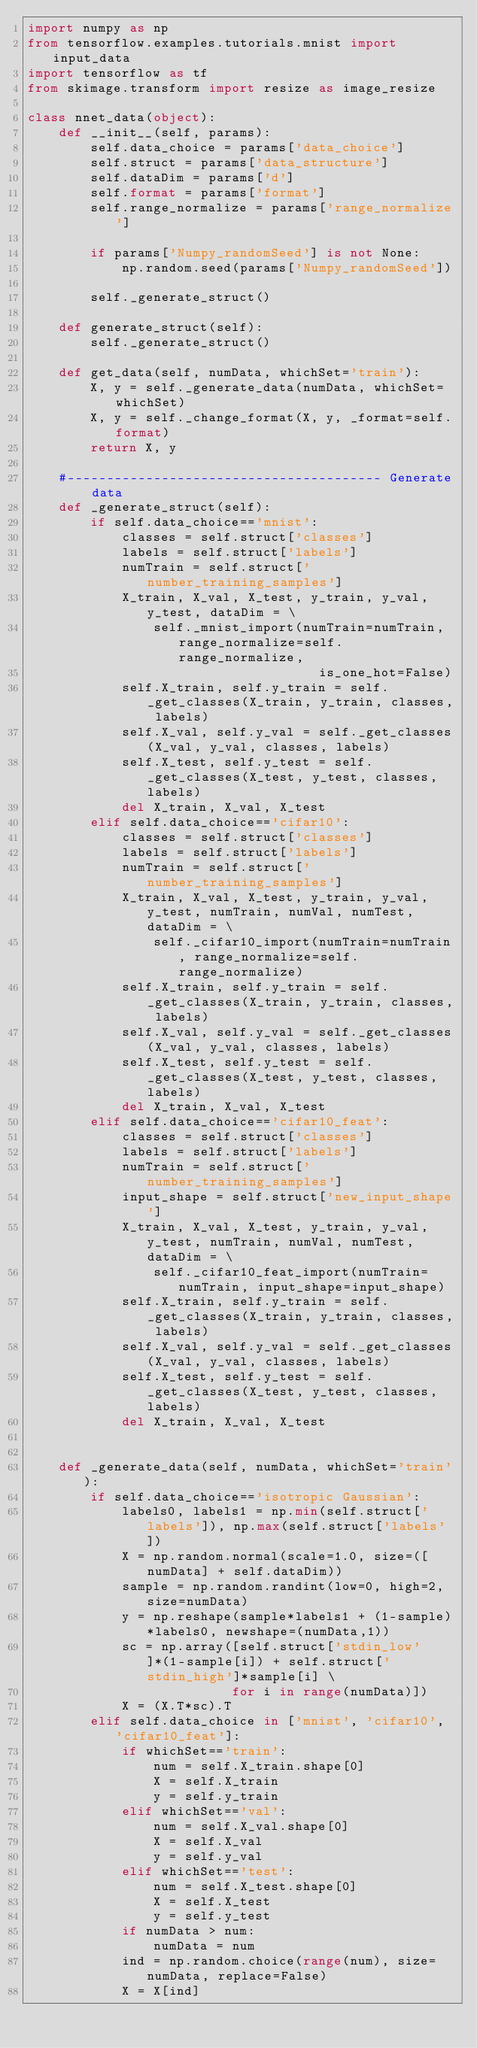<code> <loc_0><loc_0><loc_500><loc_500><_Python_>import numpy as np
from tensorflow.examples.tutorials.mnist import input_data
import tensorflow as tf
from skimage.transform import resize as image_resize

class nnet_data(object):
    def __init__(self, params):
        self.data_choice = params['data_choice']
        self.struct = params['data_structure']
        self.dataDim = params['d']
        self.format = params['format']
        self.range_normalize = params['range_normalize']
        
        if params['Numpy_randomSeed'] is not None:
            np.random.seed(params['Numpy_randomSeed'])                 
        
        self._generate_struct()
            
    def generate_struct(self):        
        self._generate_struct()
        
    def get_data(self, numData, whichSet='train'):
        X, y = self._generate_data(numData, whichSet=whichSet)
        X, y = self._change_format(X, y, _format=self.format)
        return X, y
    
    #---------------------------------------- Generate data
    def _generate_struct(self):        
        if self.data_choice=='mnist':            
            classes = self.struct['classes']
            labels = self.struct['labels']
            numTrain = self.struct['number_training_samples']
            X_train, X_val, X_test, y_train, y_val, y_test, dataDim = \
                self._mnist_import(numTrain=numTrain, range_normalize=self.range_normalize, 
                                     is_one_hot=False)
            self.X_train, self.y_train = self._get_classes(X_train, y_train, classes, labels)
            self.X_val, self.y_val = self._get_classes(X_val, y_val, classes, labels)
            self.X_test, self.y_test = self._get_classes(X_test, y_test, classes, labels)  
            del X_train, X_val, X_test
        elif self.data_choice=='cifar10':            
            classes = self.struct['classes']
            labels = self.struct['labels']
            numTrain = self.struct['number_training_samples']
            X_train, X_val, X_test, y_train, y_val, y_test, numTrain, numVal, numTest, dataDim = \
                self._cifar10_import(numTrain=numTrain, range_normalize=self.range_normalize)
            self.X_train, self.y_train = self._get_classes(X_train, y_train, classes, labels)
            self.X_val, self.y_val = self._get_classes(X_val, y_val, classes, labels)
            self.X_test, self.y_test = self._get_classes(X_test, y_test, classes, labels)    
            del X_train, X_val, X_test
        elif self.data_choice=='cifar10_feat':
            classes = self.struct['classes']
            labels = self.struct['labels']
            numTrain = self.struct['number_training_samples']
            input_shape = self.struct['new_input_shape']
            X_train, X_val, X_test, y_train, y_val, y_test, numTrain, numVal, numTest, dataDim = \
                self._cifar10_feat_import(numTrain=numTrain, input_shape=input_shape)
            self.X_train, self.y_train = self._get_classes(X_train, y_train, classes, labels)
            self.X_val, self.y_val = self._get_classes(X_val, y_val, classes, labels)
            self.X_test, self.y_test = self._get_classes(X_test, y_test, classes, labels) 
            del X_train, X_val, X_test
            
    
    def _generate_data(self, numData, whichSet='train'):       
        if self.data_choice=='isotropic Gaussian':
            labels0, labels1 = np.min(self.struct['labels']), np.max(self.struct['labels'])
            X = np.random.normal(scale=1.0, size=([numData] + self.dataDim))            
            sample = np.random.randint(low=0, high=2, size=numData)
            y = np.reshape(sample*labels1 + (1-sample)*labels0, newshape=(numData,1))
            sc = np.array([self.struct['stdin_low']*(1-sample[i]) + self.struct['stdin_high']*sample[i] \
                          for i in range(numData)])
            X = (X.T*sc).T
        elif self.data_choice in ['mnist', 'cifar10', 'cifar10_feat']:
            if whichSet=='train':
                num = self.X_train.shape[0]
                X = self.X_train
                y = self.y_train
            elif whichSet=='val':
                num = self.X_val.shape[0]
                X = self.X_val
                y = self.y_val
            elif whichSet=='test':
                num = self.X_test.shape[0]
                X = self.X_test
                y = self.y_test                
            if numData > num:
                numData = num                
            ind = np.random.choice(range(num), size=numData, replace=False)                        
            X = X[ind]</code> 